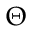<formula> <loc_0><loc_0><loc_500><loc_500>\Theta</formula> 